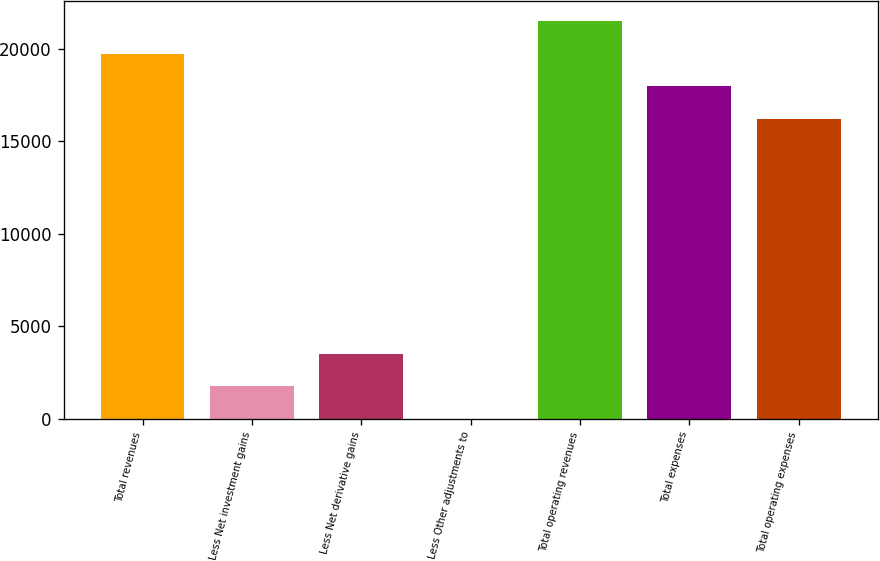<chart> <loc_0><loc_0><loc_500><loc_500><bar_chart><fcel>Total revenues<fcel>Less Net investment gains<fcel>Less Net derivative gains<fcel>Less Other adjustments to<fcel>Total operating revenues<fcel>Total expenses<fcel>Total operating expenses<nl><fcel>19734<fcel>1765.5<fcel>3530<fcel>1<fcel>21498.5<fcel>17969.5<fcel>16205<nl></chart> 